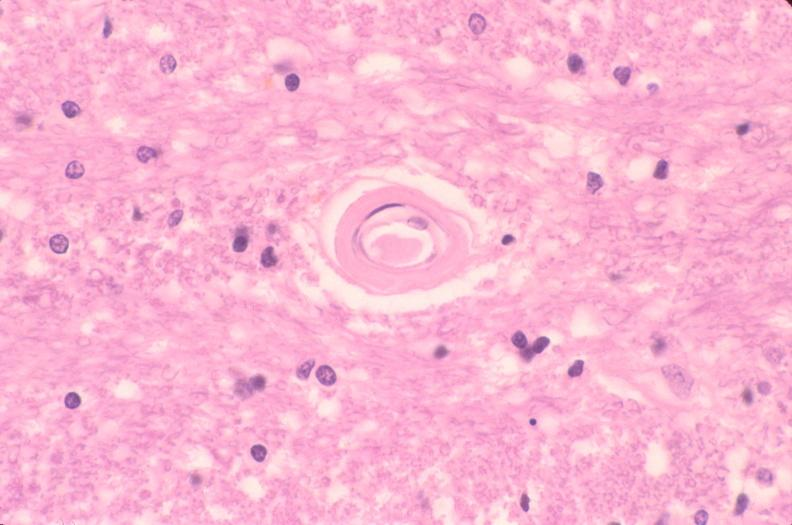what does this image show?
Answer the question using a single word or phrase. Brain 